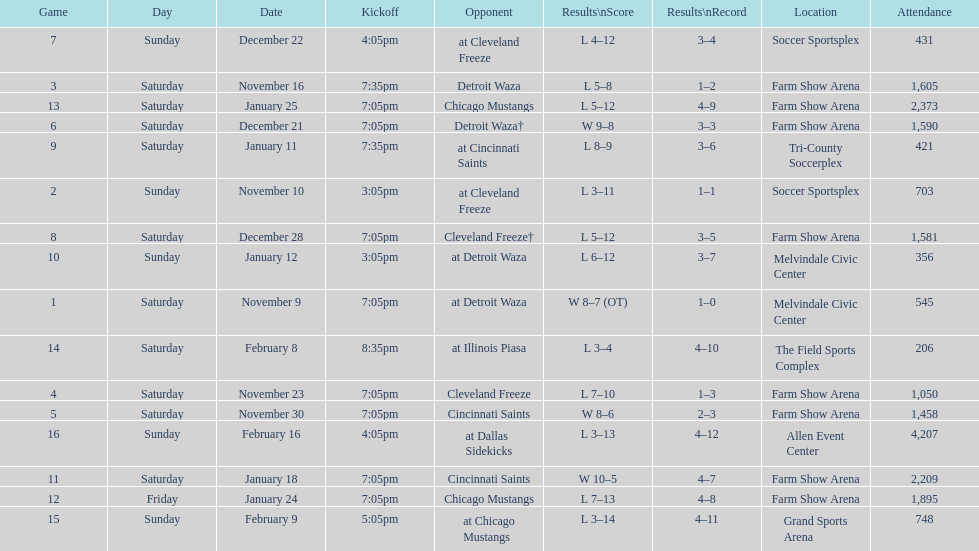How many times did the team play at home but did not win? 5. 